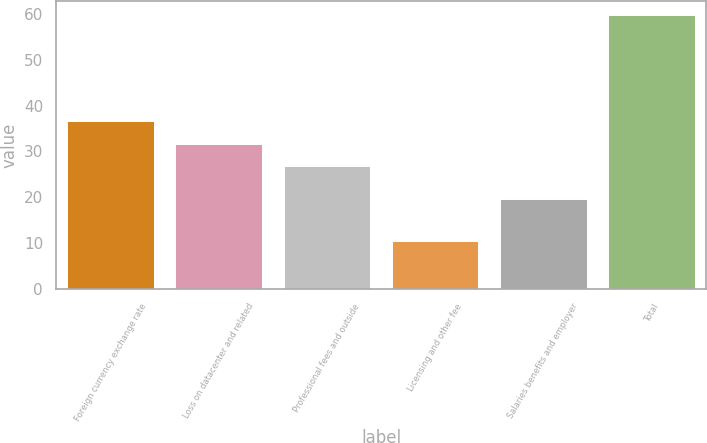Convert chart. <chart><loc_0><loc_0><loc_500><loc_500><bar_chart><fcel>Foreign currency exchange rate<fcel>Loss on datacenter and related<fcel>Professional fees and outside<fcel>Licensing and other fee<fcel>Salaries benefits and employer<fcel>Total<nl><fcel>36.66<fcel>31.73<fcel>26.8<fcel>10.5<fcel>19.6<fcel>59.8<nl></chart> 